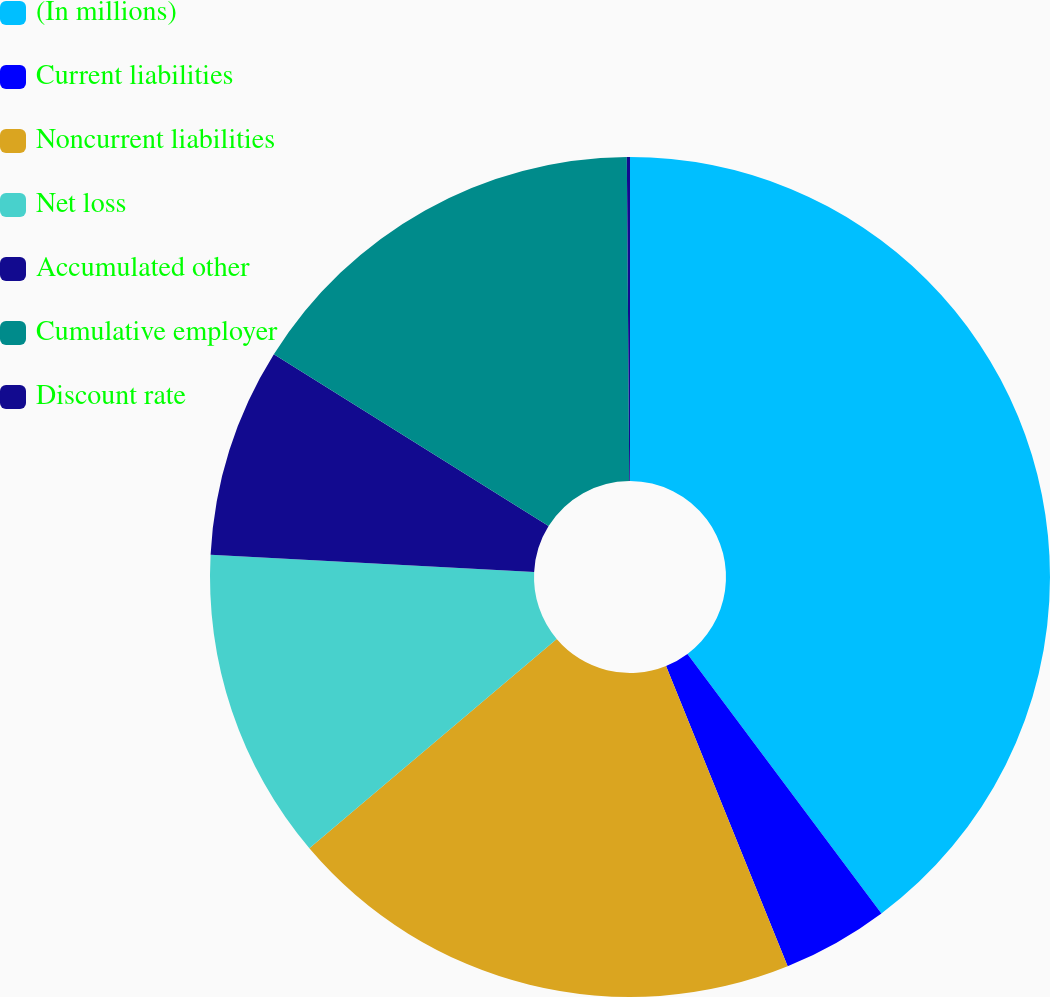Convert chart to OTSL. <chart><loc_0><loc_0><loc_500><loc_500><pie_chart><fcel>(In millions)<fcel>Current liabilities<fcel>Noncurrent liabilities<fcel>Net loss<fcel>Accumulated other<fcel>Cumulative employer<fcel>Discount rate<nl><fcel>39.79%<fcel>4.09%<fcel>19.95%<fcel>12.02%<fcel>8.05%<fcel>15.99%<fcel>0.12%<nl></chart> 